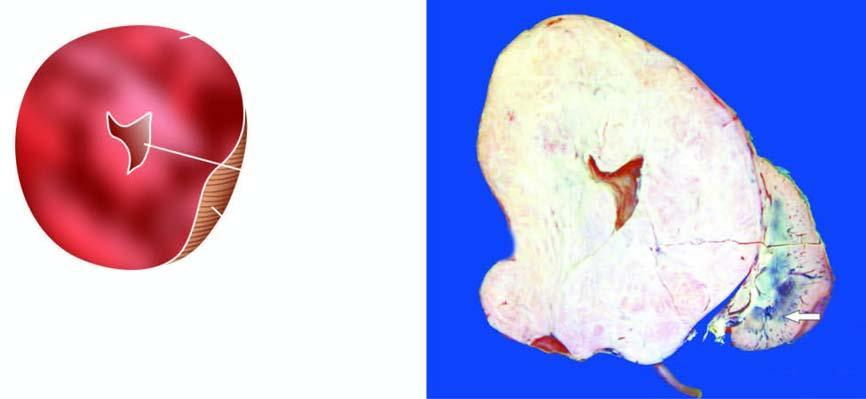does the sectioned surface show replacement of almost whole kidney by the tumour leaving a thin strip of compressed renal tissue at lower end arrow?
Answer the question using a single word or phrase. Yes 